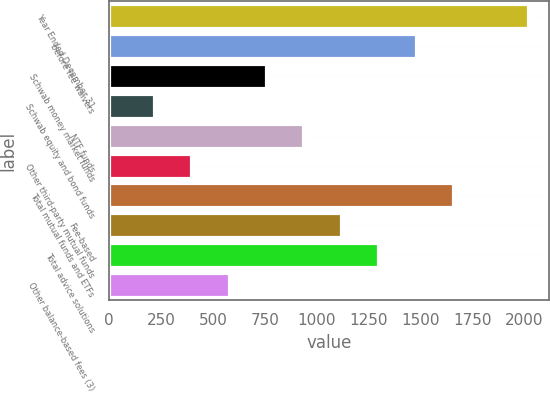Convert chart to OTSL. <chart><loc_0><loc_0><loc_500><loc_500><bar_chart><fcel>Year Ended December 31<fcel>before fee waivers<fcel>Schwab money market funds<fcel>Schwab equity and bond funds<fcel>NTF funds<fcel>Other third-party mutual funds<fcel>Total mutual funds and ETFs<fcel>Fee-based<fcel>Total advice solutions<fcel>Other balance-based fees (3)<nl><fcel>2015<fcel>1475.6<fcel>756.4<fcel>217<fcel>936.2<fcel>396.8<fcel>1655.4<fcel>1116<fcel>1295.8<fcel>576.6<nl></chart> 